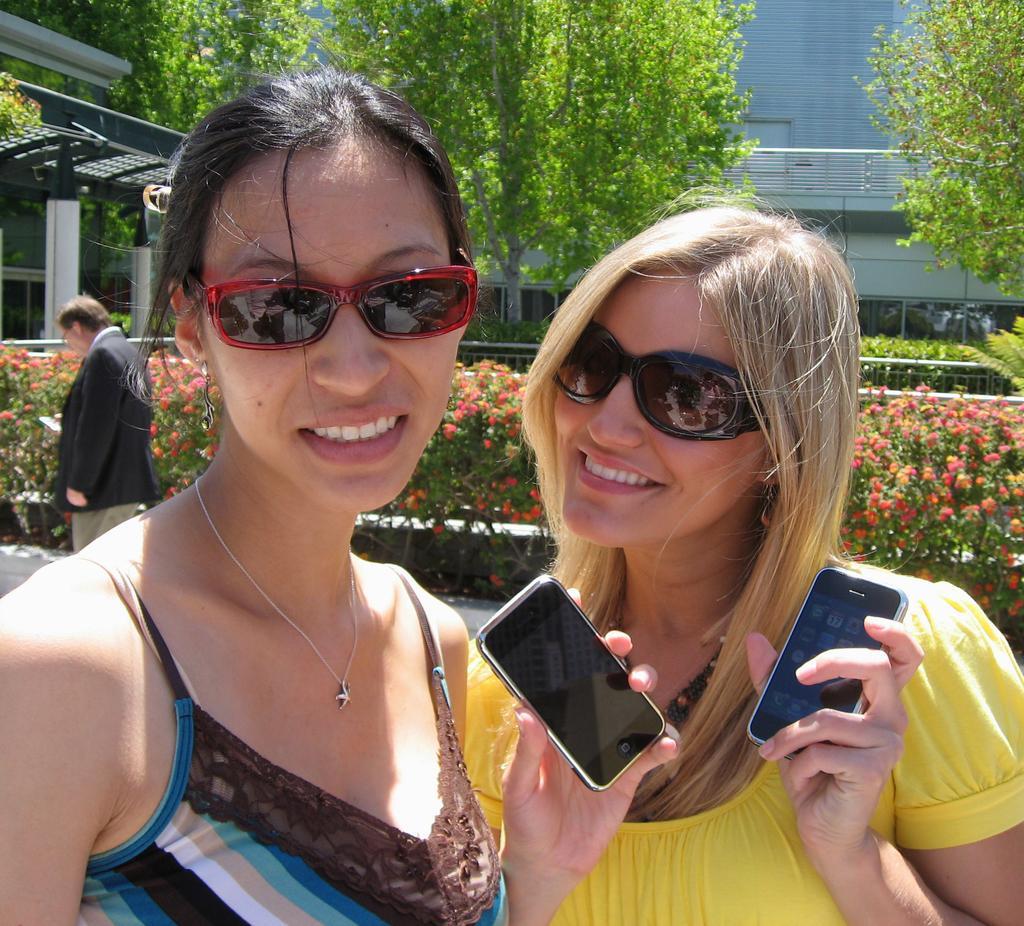Could you give a brief overview of what you see in this image? In this pictures there are two ladies in the center of the image, by holding their phones and there is a man on the left side of the image, there is greenery and a building in the background area of the image. 